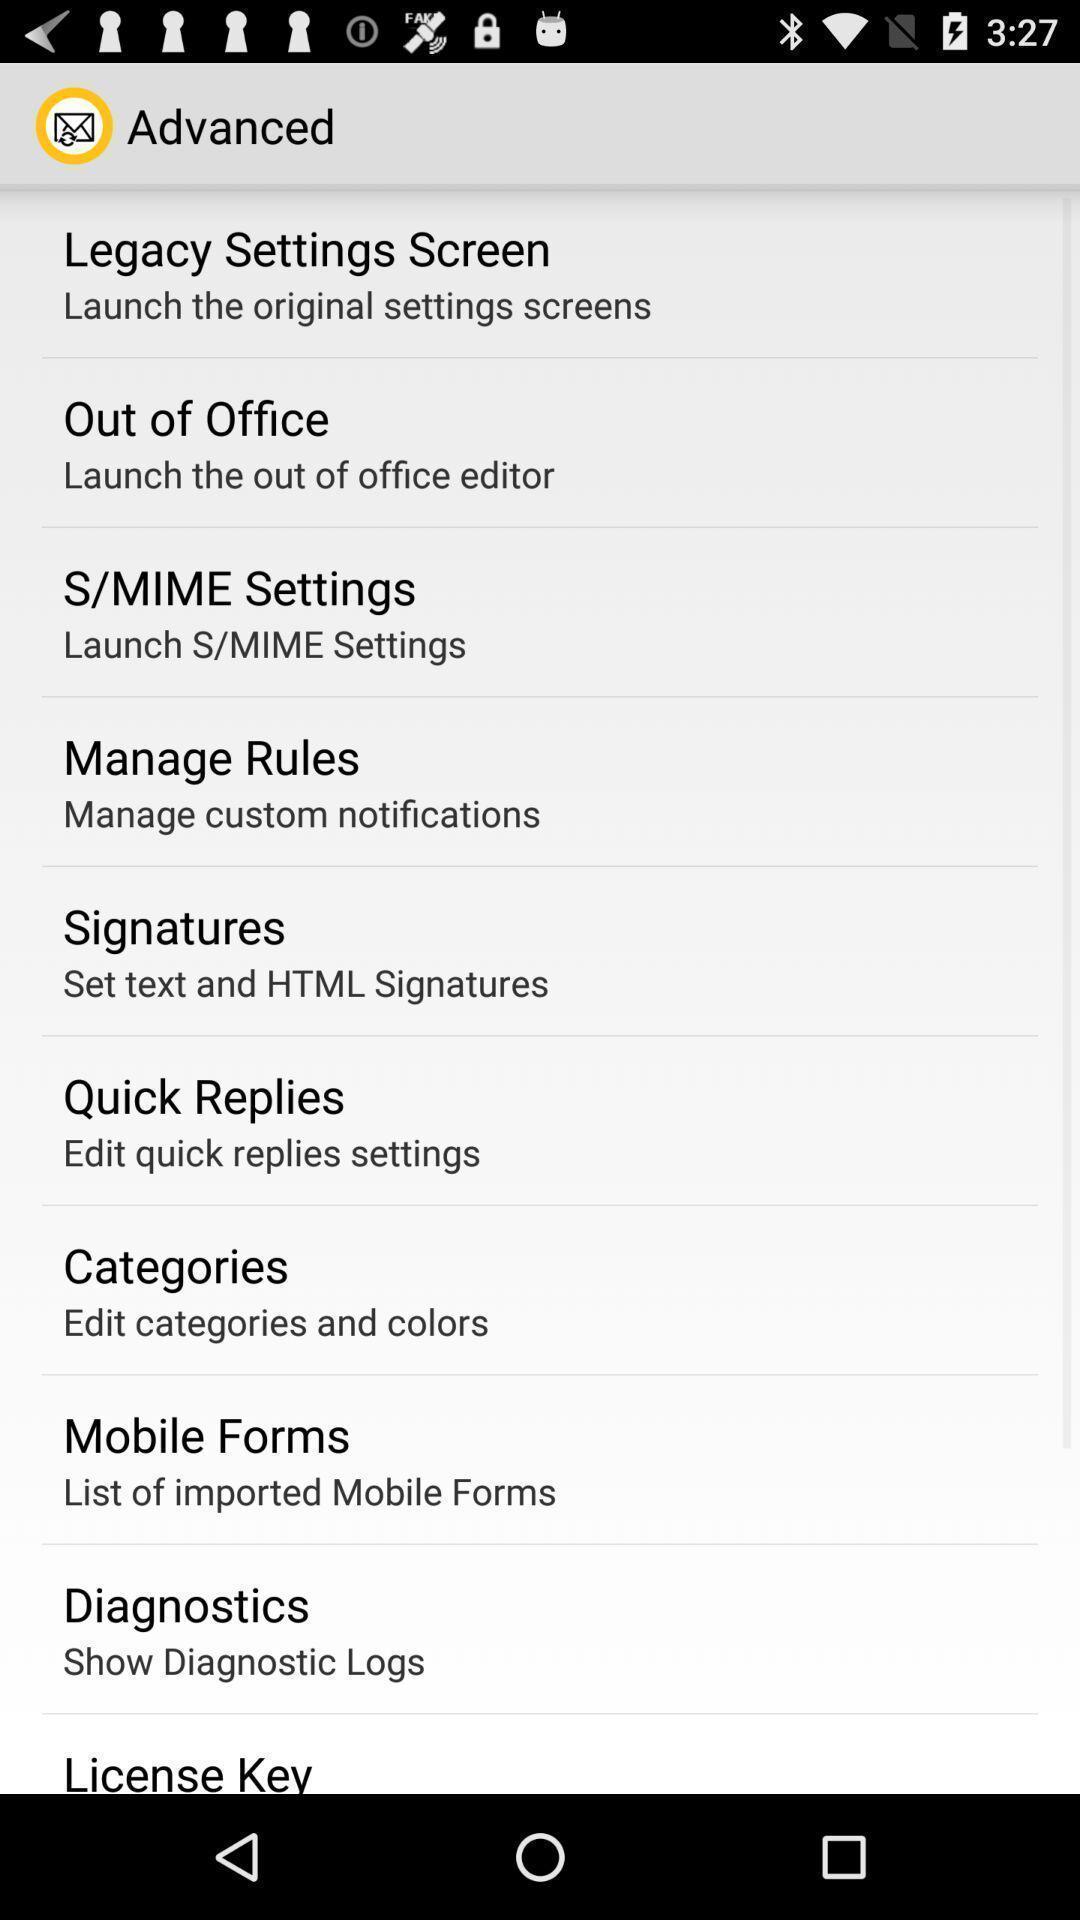Describe the key features of this screenshot. Page showing different settings. 